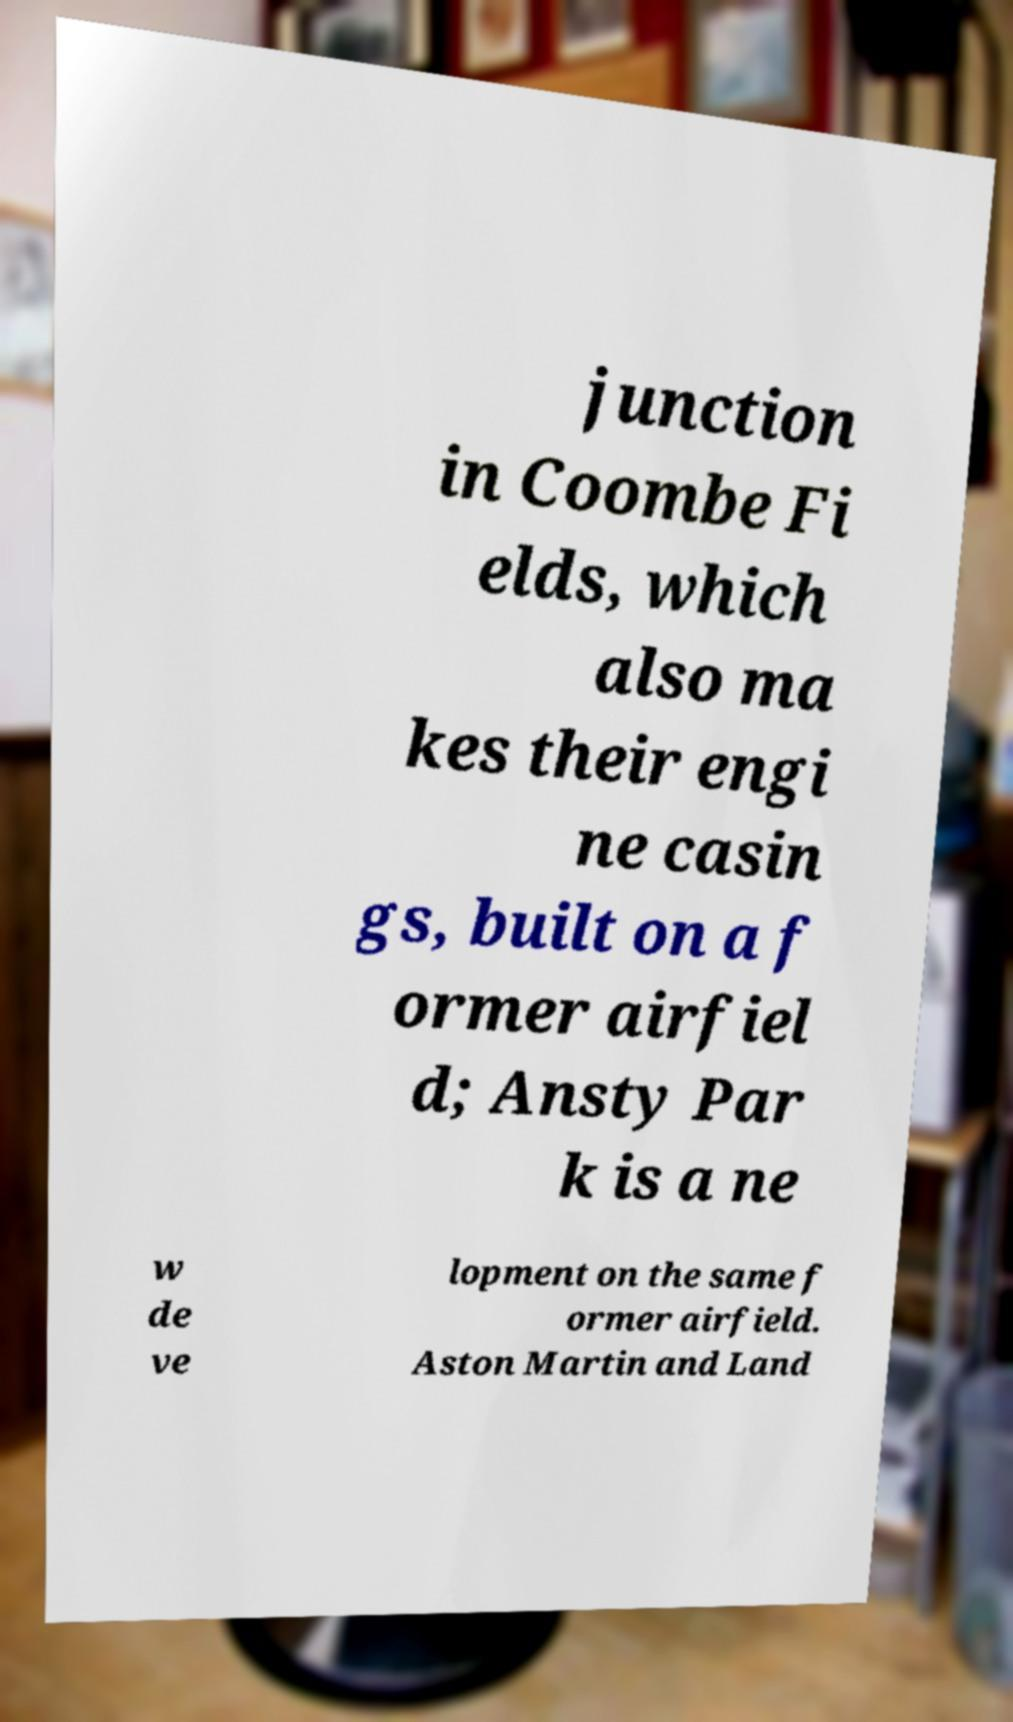Could you assist in decoding the text presented in this image and type it out clearly? junction in Coombe Fi elds, which also ma kes their engi ne casin gs, built on a f ormer airfiel d; Ansty Par k is a ne w de ve lopment on the same f ormer airfield. Aston Martin and Land 